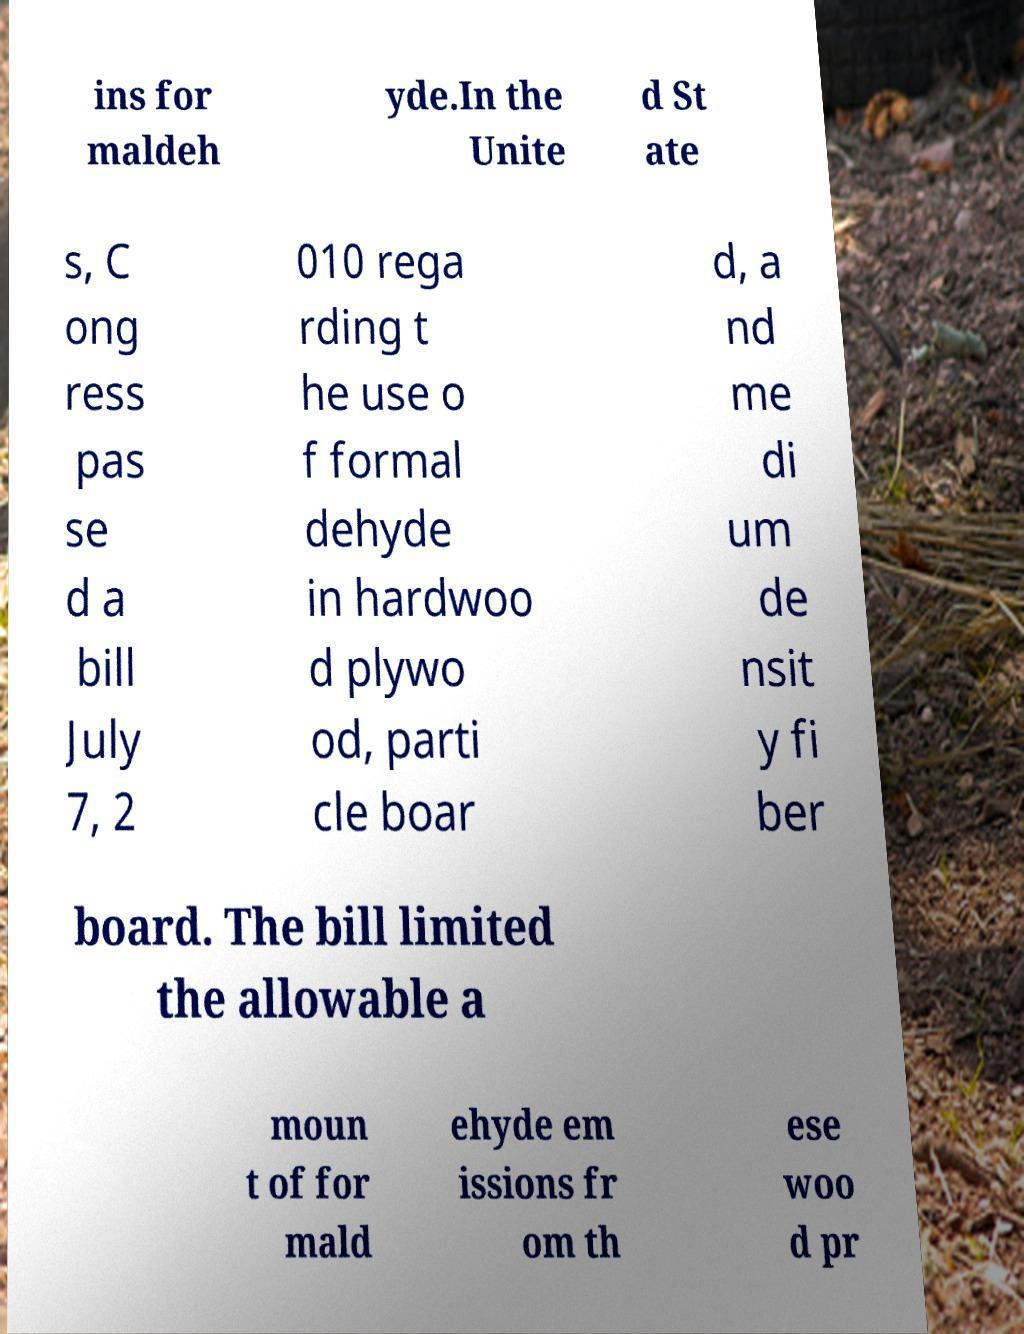Please identify and transcribe the text found in this image. ins for maldeh yde.In the Unite d St ate s, C ong ress pas se d a bill July 7, 2 010 rega rding t he use o f formal dehyde in hardwoo d plywo od, parti cle boar d, a nd me di um de nsit y fi ber board. The bill limited the allowable a moun t of for mald ehyde em issions fr om th ese woo d pr 